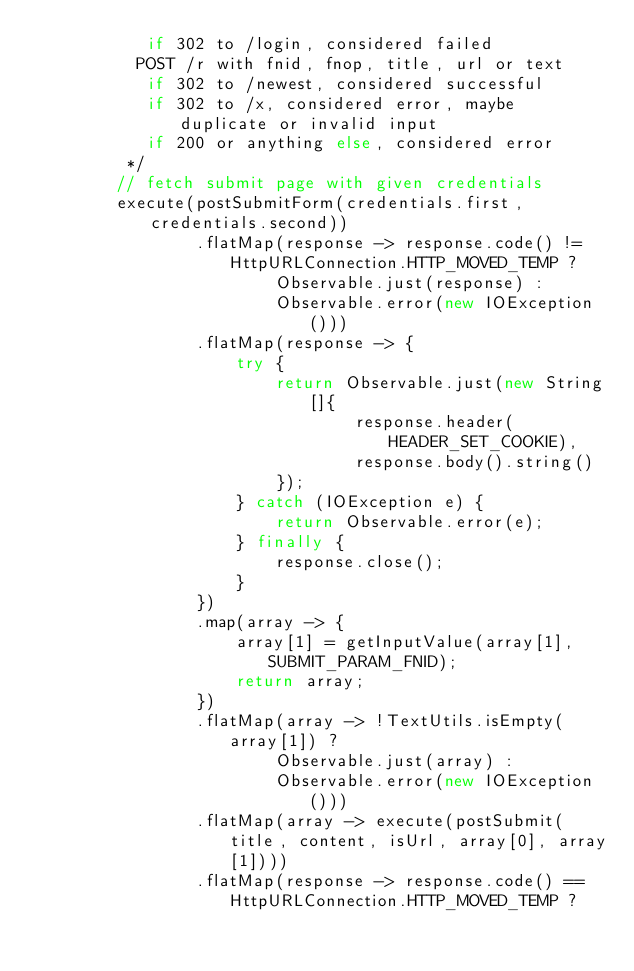Convert code to text. <code><loc_0><loc_0><loc_500><loc_500><_Java_>           if 302 to /login, considered failed
          POST /r with fnid, fnop, title, url or text
           if 302 to /newest, considered successful
           if 302 to /x, considered error, maybe duplicate or invalid input
           if 200 or anything else, considered error
         */
        // fetch submit page with given credentials
        execute(postSubmitForm(credentials.first, credentials.second))
                .flatMap(response -> response.code() != HttpURLConnection.HTTP_MOVED_TEMP ?
                        Observable.just(response) :
                        Observable.error(new IOException()))
                .flatMap(response -> {
                    try {
                        return Observable.just(new String[]{
                                response.header(HEADER_SET_COOKIE),
                                response.body().string()
                        });
                    } catch (IOException e) {
                        return Observable.error(e);
                    } finally {
                        response.close();
                    }
                })
                .map(array -> {
                    array[1] = getInputValue(array[1], SUBMIT_PARAM_FNID);
                    return array;
                })
                .flatMap(array -> !TextUtils.isEmpty(array[1]) ?
                        Observable.just(array) :
                        Observable.error(new IOException()))
                .flatMap(array -> execute(postSubmit(title, content, isUrl, array[0], array[1])))
                .flatMap(response -> response.code() == HttpURLConnection.HTTP_MOVED_TEMP ?</code> 